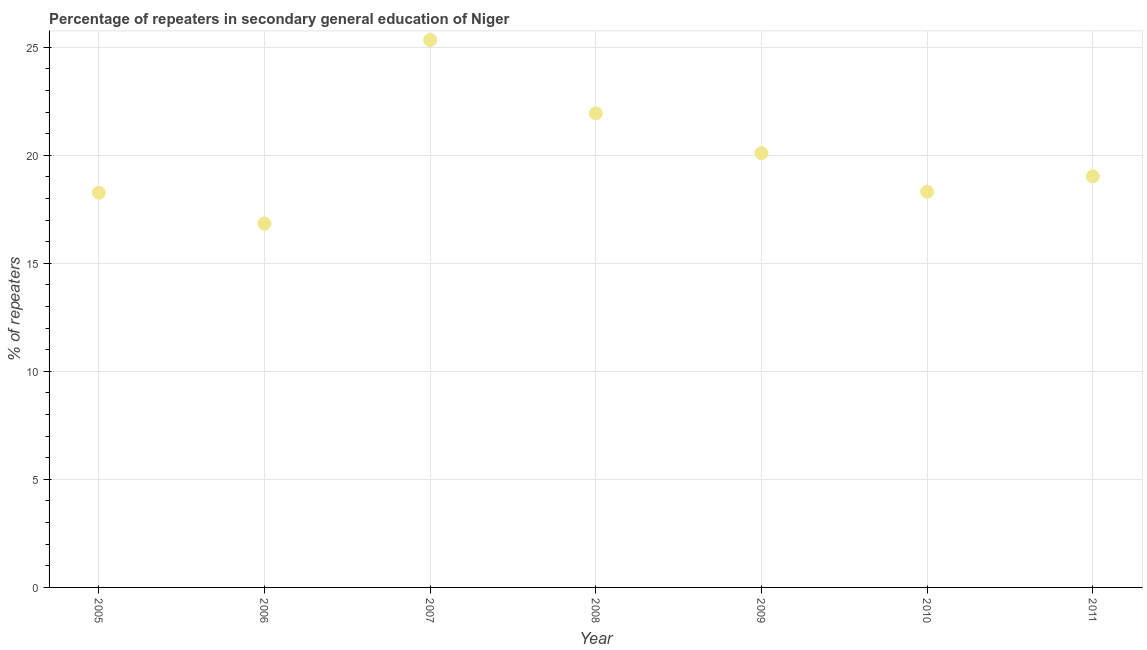What is the percentage of repeaters in 2009?
Provide a succinct answer. 20.1. Across all years, what is the maximum percentage of repeaters?
Keep it short and to the point. 25.33. Across all years, what is the minimum percentage of repeaters?
Provide a succinct answer. 16.83. In which year was the percentage of repeaters minimum?
Make the answer very short. 2006. What is the sum of the percentage of repeaters?
Offer a very short reply. 139.8. What is the difference between the percentage of repeaters in 2008 and 2011?
Your answer should be compact. 2.92. What is the average percentage of repeaters per year?
Offer a terse response. 19.97. What is the median percentage of repeaters?
Your answer should be compact. 19.02. In how many years, is the percentage of repeaters greater than 19 %?
Keep it short and to the point. 4. What is the ratio of the percentage of repeaters in 2007 to that in 2011?
Your answer should be compact. 1.33. Is the percentage of repeaters in 2008 less than that in 2011?
Your answer should be very brief. No. Is the difference between the percentage of repeaters in 2007 and 2008 greater than the difference between any two years?
Your answer should be very brief. No. What is the difference between the highest and the second highest percentage of repeaters?
Make the answer very short. 3.39. What is the difference between the highest and the lowest percentage of repeaters?
Offer a very short reply. 8.5. In how many years, is the percentage of repeaters greater than the average percentage of repeaters taken over all years?
Give a very brief answer. 3. How many dotlines are there?
Make the answer very short. 1. Does the graph contain any zero values?
Offer a very short reply. No. Does the graph contain grids?
Keep it short and to the point. Yes. What is the title of the graph?
Make the answer very short. Percentage of repeaters in secondary general education of Niger. What is the label or title of the X-axis?
Your response must be concise. Year. What is the label or title of the Y-axis?
Your answer should be compact. % of repeaters. What is the % of repeaters in 2005?
Ensure brevity in your answer.  18.26. What is the % of repeaters in 2006?
Make the answer very short. 16.83. What is the % of repeaters in 2007?
Make the answer very short. 25.33. What is the % of repeaters in 2008?
Keep it short and to the point. 21.94. What is the % of repeaters in 2009?
Your answer should be very brief. 20.1. What is the % of repeaters in 2010?
Provide a succinct answer. 18.31. What is the % of repeaters in 2011?
Provide a succinct answer. 19.02. What is the difference between the % of repeaters in 2005 and 2006?
Your answer should be compact. 1.43. What is the difference between the % of repeaters in 2005 and 2007?
Keep it short and to the point. -7.07. What is the difference between the % of repeaters in 2005 and 2008?
Offer a very short reply. -3.68. What is the difference between the % of repeaters in 2005 and 2009?
Make the answer very short. -1.83. What is the difference between the % of repeaters in 2005 and 2010?
Offer a terse response. -0.05. What is the difference between the % of repeaters in 2005 and 2011?
Provide a succinct answer. -0.76. What is the difference between the % of repeaters in 2006 and 2007?
Offer a very short reply. -8.5. What is the difference between the % of repeaters in 2006 and 2008?
Your answer should be compact. -5.1. What is the difference between the % of repeaters in 2006 and 2009?
Give a very brief answer. -3.26. What is the difference between the % of repeaters in 2006 and 2010?
Keep it short and to the point. -1.47. What is the difference between the % of repeaters in 2006 and 2011?
Offer a terse response. -2.19. What is the difference between the % of repeaters in 2007 and 2008?
Your answer should be very brief. 3.39. What is the difference between the % of repeaters in 2007 and 2009?
Your response must be concise. 5.24. What is the difference between the % of repeaters in 2007 and 2010?
Offer a very short reply. 7.02. What is the difference between the % of repeaters in 2007 and 2011?
Provide a succinct answer. 6.31. What is the difference between the % of repeaters in 2008 and 2009?
Offer a terse response. 1.84. What is the difference between the % of repeaters in 2008 and 2010?
Your answer should be very brief. 3.63. What is the difference between the % of repeaters in 2008 and 2011?
Offer a very short reply. 2.92. What is the difference between the % of repeaters in 2009 and 2010?
Your answer should be very brief. 1.79. What is the difference between the % of repeaters in 2009 and 2011?
Make the answer very short. 1.07. What is the difference between the % of repeaters in 2010 and 2011?
Make the answer very short. -0.71. What is the ratio of the % of repeaters in 2005 to that in 2006?
Keep it short and to the point. 1.08. What is the ratio of the % of repeaters in 2005 to that in 2007?
Offer a terse response. 0.72. What is the ratio of the % of repeaters in 2005 to that in 2008?
Your answer should be compact. 0.83. What is the ratio of the % of repeaters in 2005 to that in 2009?
Offer a very short reply. 0.91. What is the ratio of the % of repeaters in 2005 to that in 2010?
Provide a succinct answer. 1. What is the ratio of the % of repeaters in 2005 to that in 2011?
Offer a very short reply. 0.96. What is the ratio of the % of repeaters in 2006 to that in 2007?
Offer a terse response. 0.67. What is the ratio of the % of repeaters in 2006 to that in 2008?
Make the answer very short. 0.77. What is the ratio of the % of repeaters in 2006 to that in 2009?
Give a very brief answer. 0.84. What is the ratio of the % of repeaters in 2006 to that in 2010?
Ensure brevity in your answer.  0.92. What is the ratio of the % of repeaters in 2006 to that in 2011?
Offer a terse response. 0.89. What is the ratio of the % of repeaters in 2007 to that in 2008?
Ensure brevity in your answer.  1.16. What is the ratio of the % of repeaters in 2007 to that in 2009?
Keep it short and to the point. 1.26. What is the ratio of the % of repeaters in 2007 to that in 2010?
Offer a very short reply. 1.38. What is the ratio of the % of repeaters in 2007 to that in 2011?
Keep it short and to the point. 1.33. What is the ratio of the % of repeaters in 2008 to that in 2009?
Offer a very short reply. 1.09. What is the ratio of the % of repeaters in 2008 to that in 2010?
Your answer should be very brief. 1.2. What is the ratio of the % of repeaters in 2008 to that in 2011?
Your response must be concise. 1.15. What is the ratio of the % of repeaters in 2009 to that in 2010?
Give a very brief answer. 1.1. What is the ratio of the % of repeaters in 2009 to that in 2011?
Make the answer very short. 1.06. What is the ratio of the % of repeaters in 2010 to that in 2011?
Ensure brevity in your answer.  0.96. 